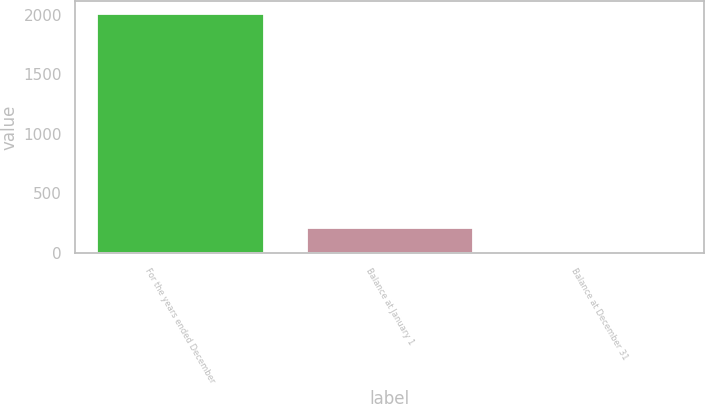Convert chart to OTSL. <chart><loc_0><loc_0><loc_500><loc_500><bar_chart><fcel>For the years ended December<fcel>Balance at January 1<fcel>Balance at December 31<nl><fcel>2015<fcel>221.3<fcel>22<nl></chart> 